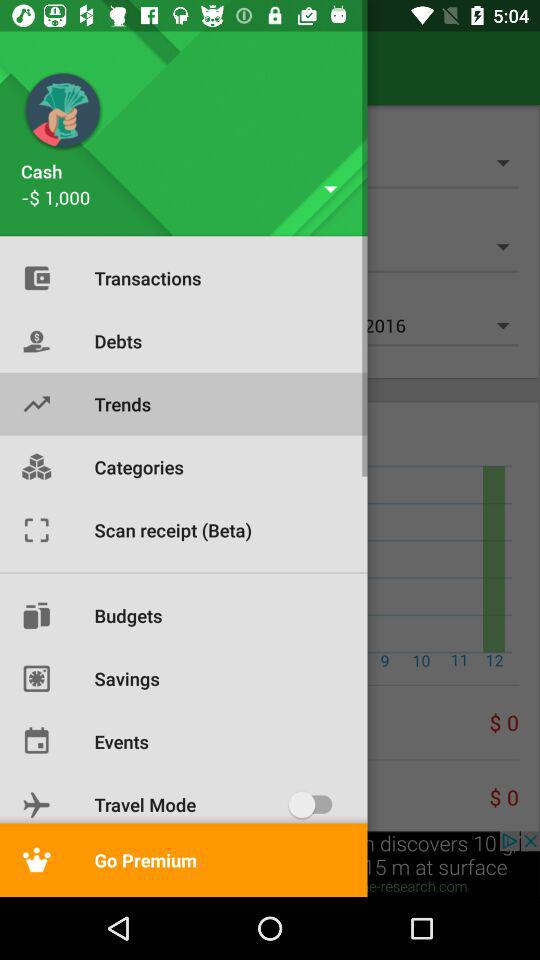What is the balance? The balance is -$1,000. 